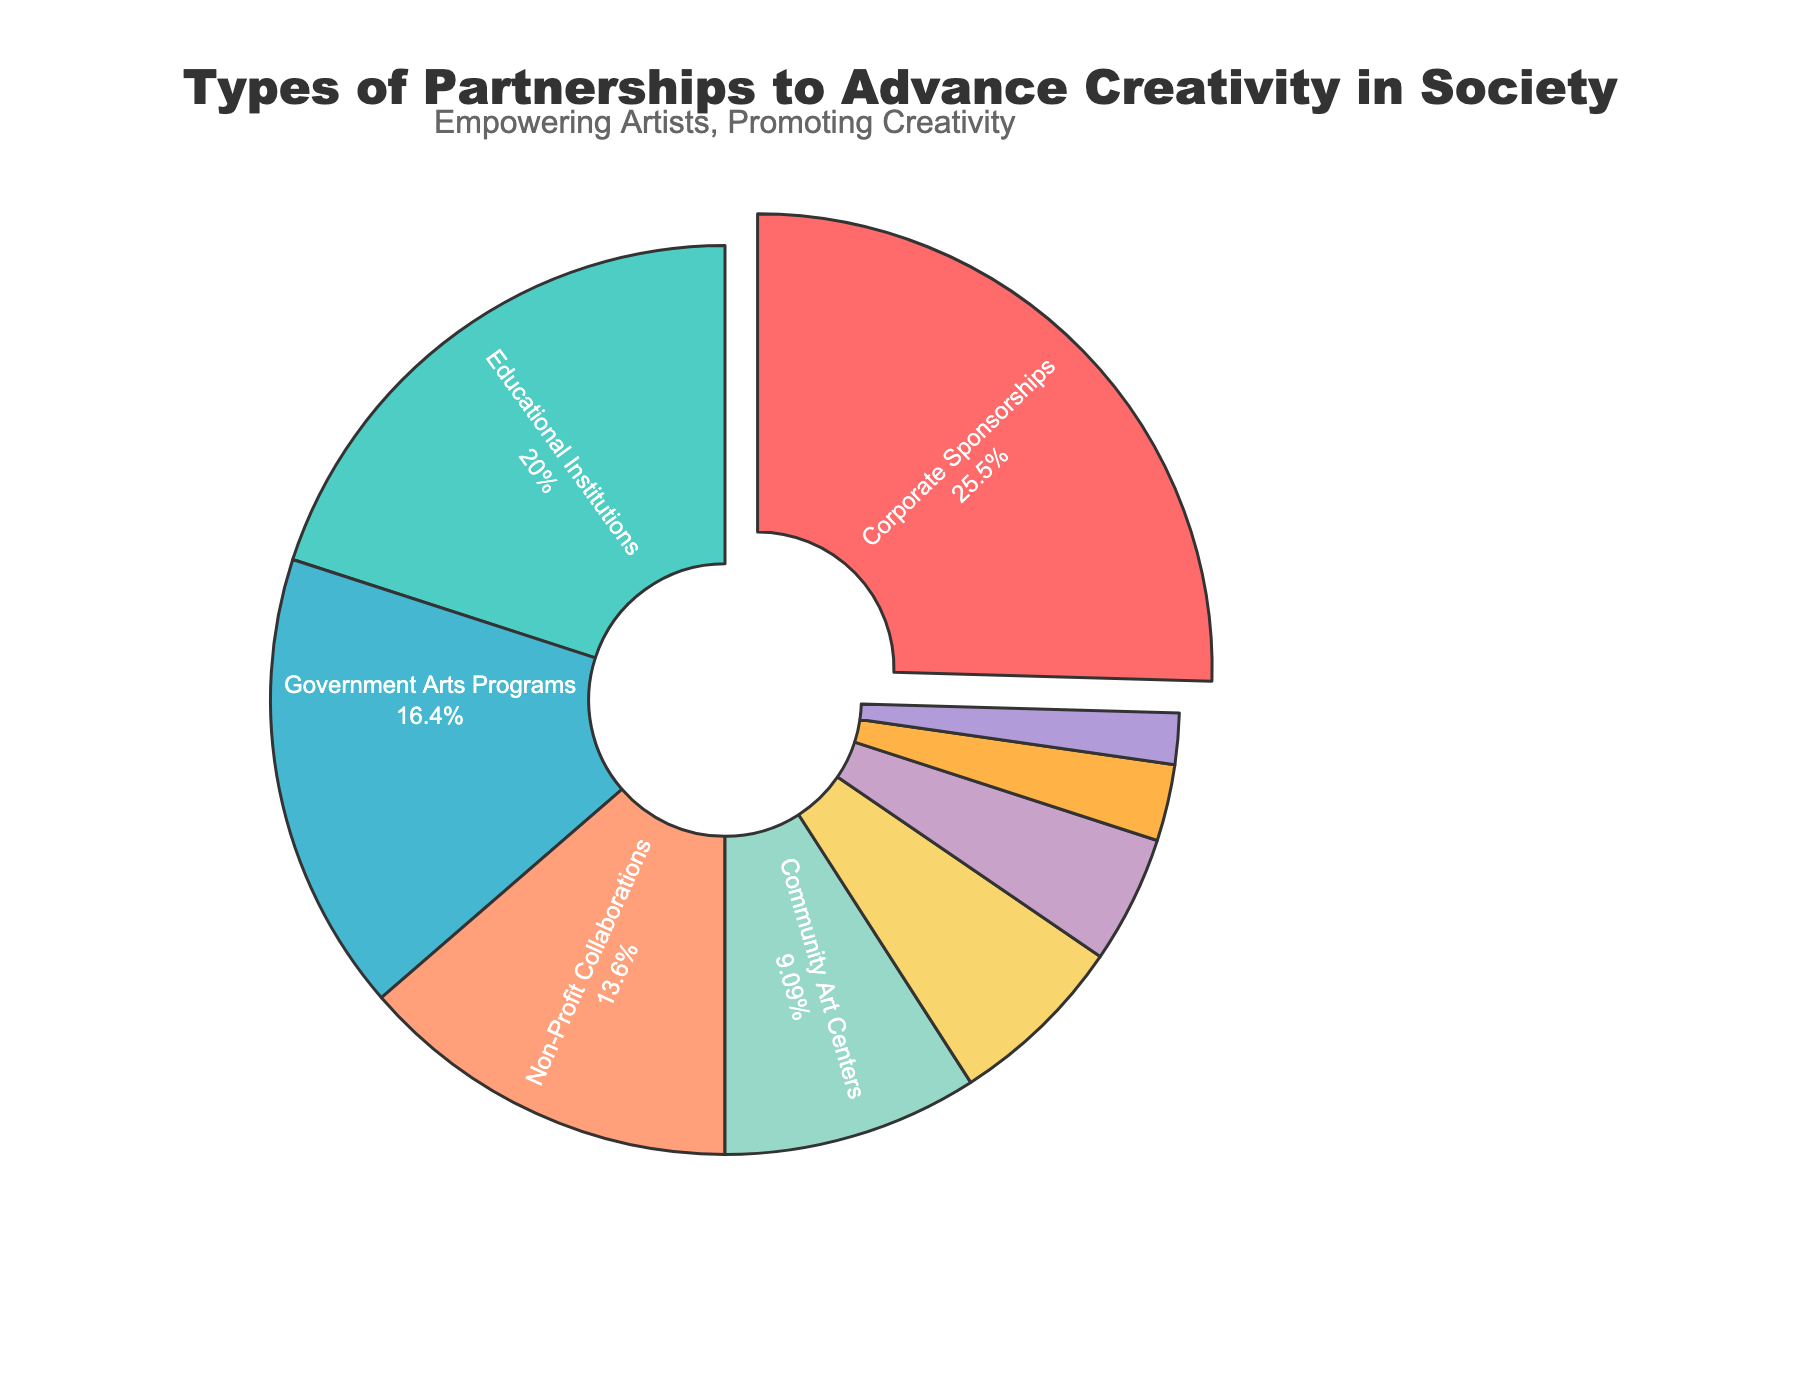Which partnership type accounts for the largest percentage? By looking at the pie chart, the segment that is "pulled out" represents the largest percentage. In this case, it is Corporate Sponsorships.
Answer: Corporate Sponsorships What percentage of partnerships are formed with Educational Institutions? Refer to the section labeled "Educational Institutions" on the pie chart, which shows its value percentage-wise.
Answer: 22% How much more popular are Corporate Sponsorships compared to Government Arts Programs? Find the percentages for Corporate Sponsorships (28%) and Government Arts Programs (18%), and subtract the latter from the former (28 - 18).
Answer: 10% Which partnership types account for at least 20% of the total? Look for segments that have percentages of 20% or higher and identify their labels. Here, only Corporate Sponsorships (28%) and Educational Institutions (22%) meet this criterion.
Answer: Corporate Sponsorships, Educational Institutions How do Non-Profit Collaborations compare to Community Art Centers in terms of percentage? Locate both segments' percentages (Non-Profit Collaborations at 15% and Community Art Centers at 10%), then compare the two. 15% is greater than 10%.
Answer: Non-Profit Collaborations have a higher percentage What is the combined percentage of Media and Technology Firms and Artist Residency Programs? Find and add the percentages of both segments (Media and Technology Firms at 7% and Artist Residency Programs at 5%), so 7 + 5.
Answer: 12% Which partnership type has the smallest representation? Identify the segment with the least percentage on the pie chart, which is Art Therapy Organizations at 2%.
Answer: Art Therapy Organizations What is the total percentage represented by the three partnership types with the smallest contributions? Sum the percentages for the three smallest segments: Art Therapy Organizations (2%), International Cultural Exchanges (3%), and Artist Residency Programs (5%); thus, 2 + 3 + 5.
Answer: 10% If "Government Arts Programs" increased by 10%, what would its new percentage be and how would it rank among others? Add 10% to the current percentage of Government Arts Programs (18 + 10 = 28%). If at 28%, it would tie with the current largest (Corporate Sponsorships) at 28%. It will still be among the top percentages.
Answer: 28%, tied with Corporate Sponsorships 